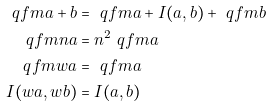<formula> <loc_0><loc_0><loc_500><loc_500>\ q f m { a + b } & = \ q f m { a } + I ( a , b ) + \ q f m { b } \\ \ q f m { n a } & = n ^ { 2 } \ q f m { a } \\ \ q f m { w a } & = \ q f m { a } \\ I ( w a , w b ) & = I ( a , b )</formula> 